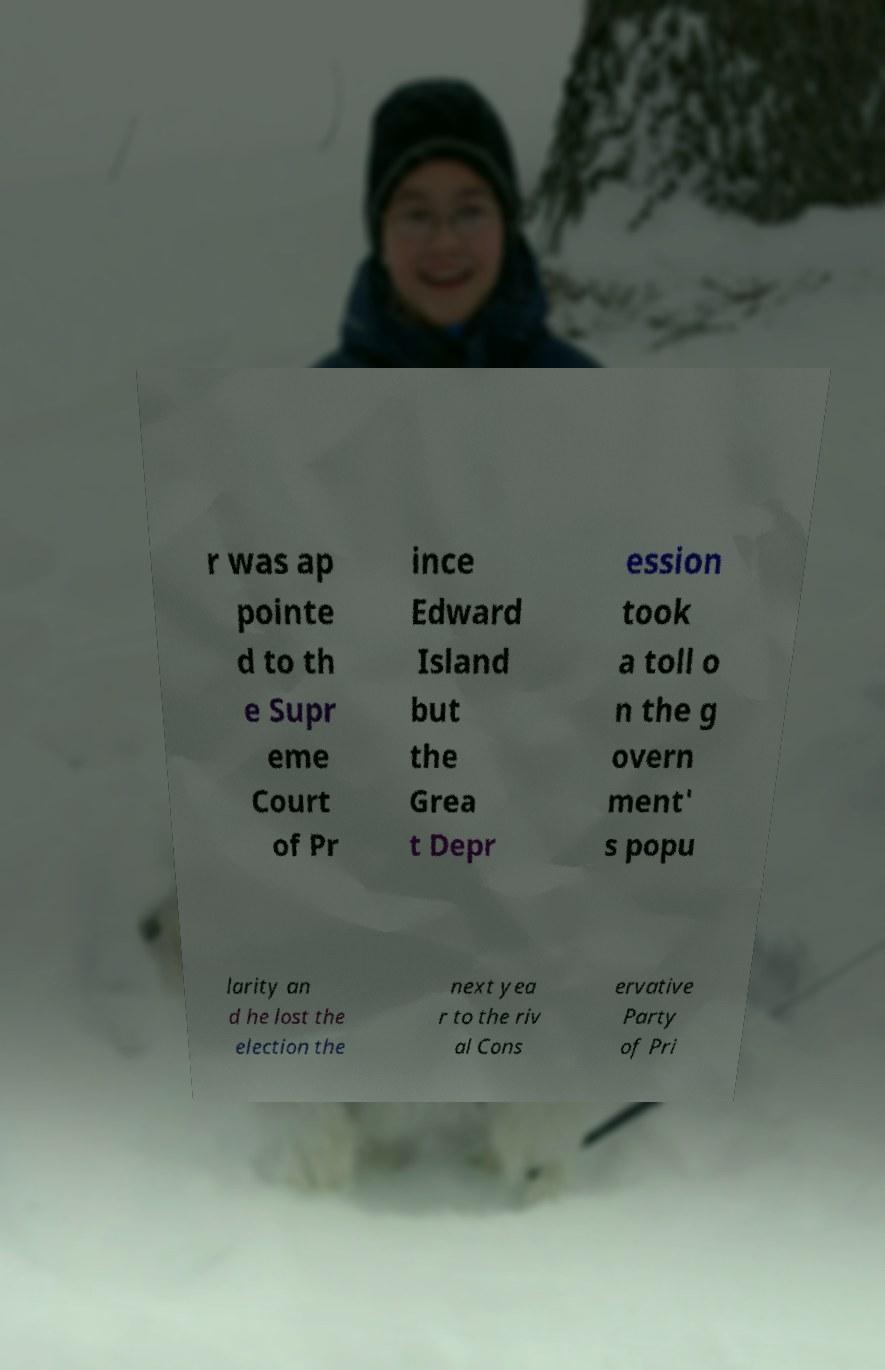Can you accurately transcribe the text from the provided image for me? r was ap pointe d to th e Supr eme Court of Pr ince Edward Island but the Grea t Depr ession took a toll o n the g overn ment' s popu larity an d he lost the election the next yea r to the riv al Cons ervative Party of Pri 